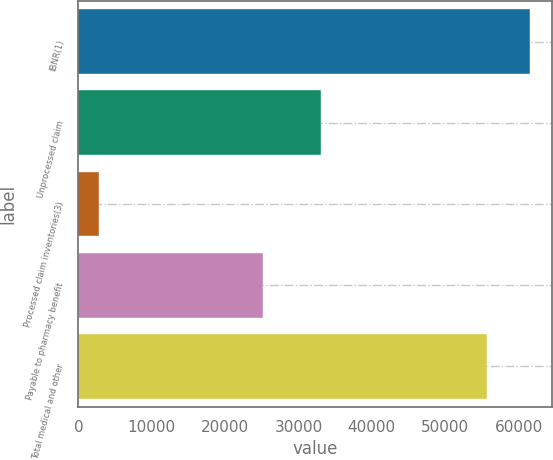Convert chart. <chart><loc_0><loc_0><loc_500><loc_500><bar_chart><fcel>IBNR(1)<fcel>Unprocessed claim<fcel>Processed claim inventories(3)<fcel>Payable to pharmacy benefit<fcel>Total medical and other<nl><fcel>61550.8<fcel>33100<fcel>2800<fcel>25187<fcel>55745<nl></chart> 